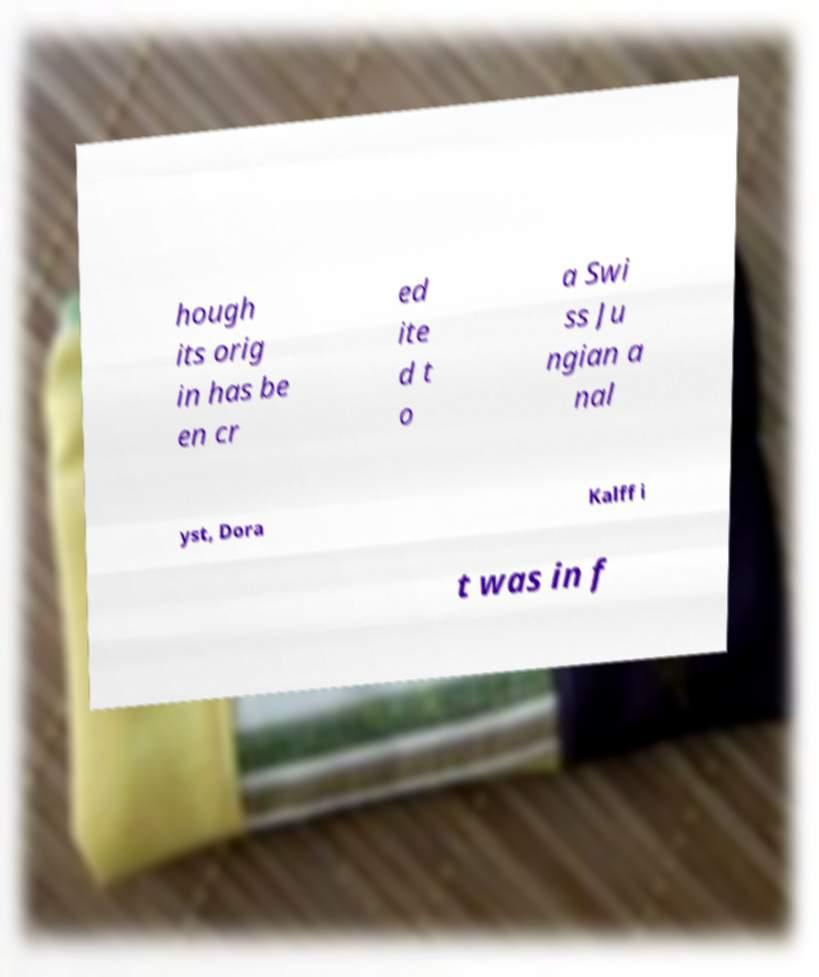There's text embedded in this image that I need extracted. Can you transcribe it verbatim? hough its orig in has be en cr ed ite d t o a Swi ss Ju ngian a nal yst, Dora Kalff i t was in f 